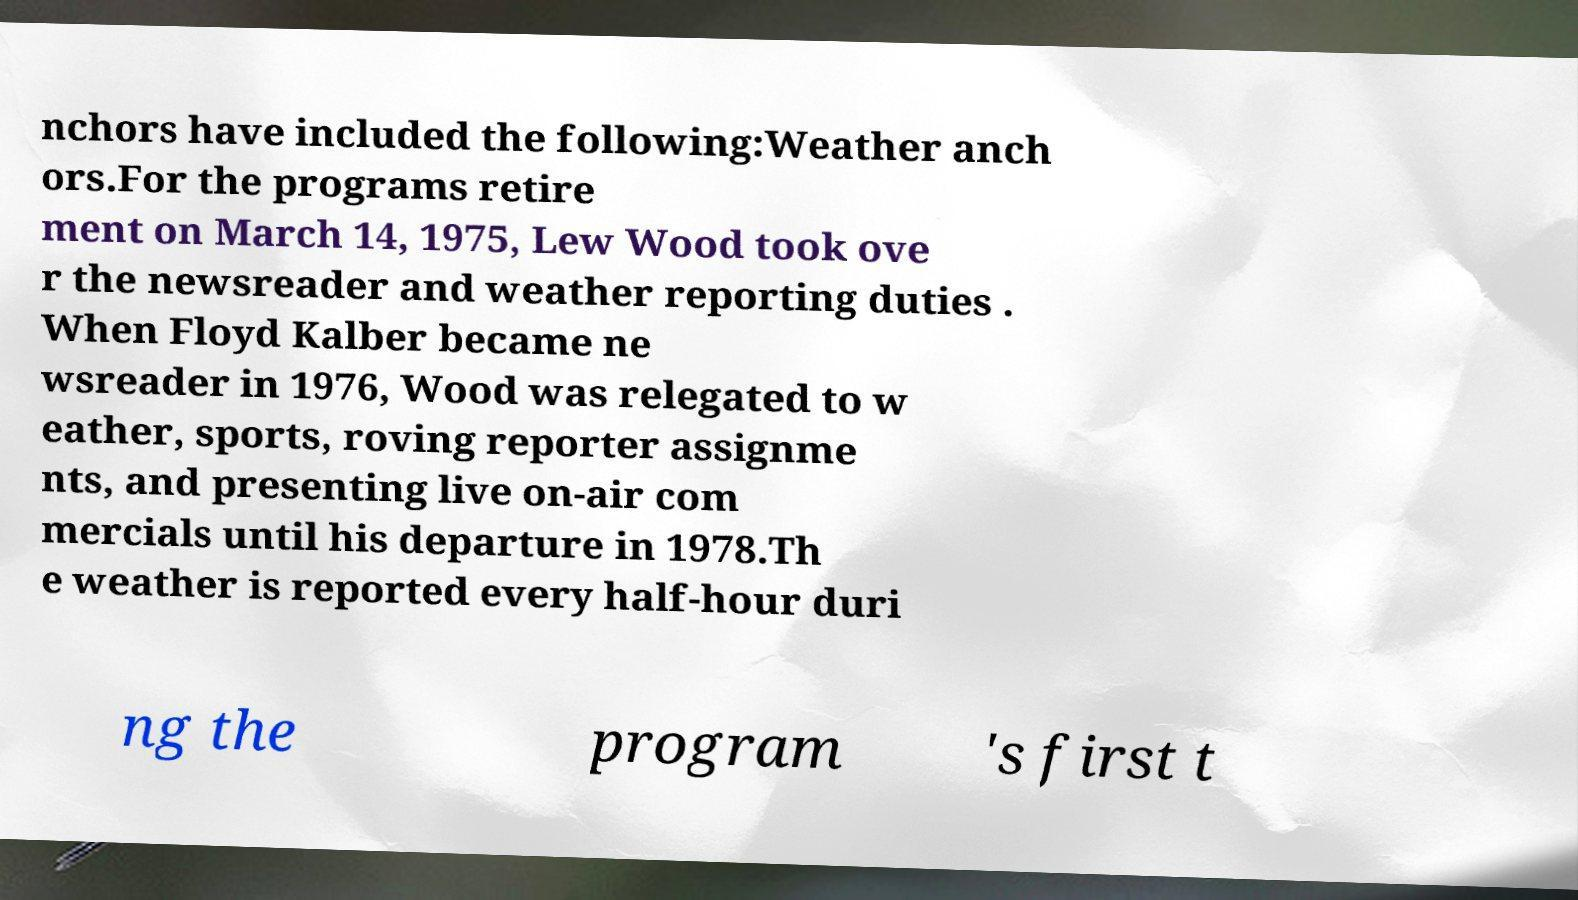Please identify and transcribe the text found in this image. nchors have included the following:Weather anch ors.For the programs retire ment on March 14, 1975, Lew Wood took ove r the newsreader and weather reporting duties . When Floyd Kalber became ne wsreader in 1976, Wood was relegated to w eather, sports, roving reporter assignme nts, and presenting live on-air com mercials until his departure in 1978.Th e weather is reported every half-hour duri ng the program 's first t 